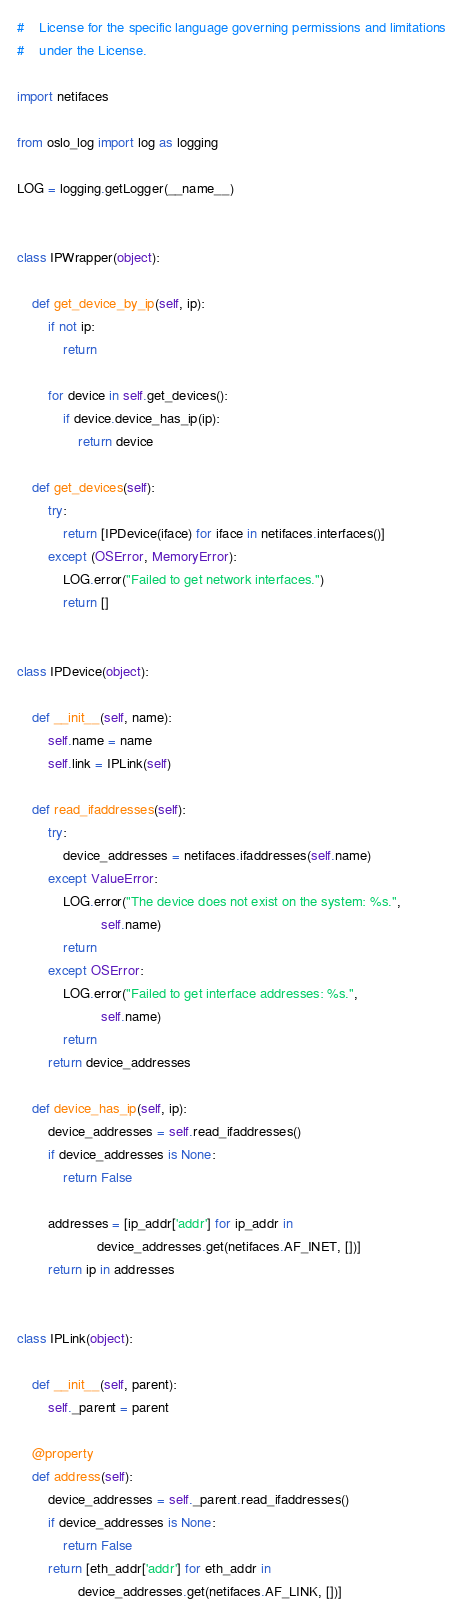Convert code to text. <code><loc_0><loc_0><loc_500><loc_500><_Python_>#    License for the specific language governing permissions and limitations
#    under the License.

import netifaces

from oslo_log import log as logging

LOG = logging.getLogger(__name__)


class IPWrapper(object):

    def get_device_by_ip(self, ip):
        if not ip:
            return

        for device in self.get_devices():
            if device.device_has_ip(ip):
                return device

    def get_devices(self):
        try:
            return [IPDevice(iface) for iface in netifaces.interfaces()]
        except (OSError, MemoryError):
            LOG.error("Failed to get network interfaces.")
            return []


class IPDevice(object):

    def __init__(self, name):
        self.name = name
        self.link = IPLink(self)

    def read_ifaddresses(self):
        try:
            device_addresses = netifaces.ifaddresses(self.name)
        except ValueError:
            LOG.error("The device does not exist on the system: %s.",
                      self.name)
            return
        except OSError:
            LOG.error("Failed to get interface addresses: %s.",
                      self.name)
            return
        return device_addresses

    def device_has_ip(self, ip):
        device_addresses = self.read_ifaddresses()
        if device_addresses is None:
            return False

        addresses = [ip_addr['addr'] for ip_addr in
                     device_addresses.get(netifaces.AF_INET, [])]
        return ip in addresses


class IPLink(object):

    def __init__(self, parent):
        self._parent = parent

    @property
    def address(self):
        device_addresses = self._parent.read_ifaddresses()
        if device_addresses is None:
            return False
        return [eth_addr['addr'] for eth_addr in
                device_addresses.get(netifaces.AF_LINK, [])]
</code> 